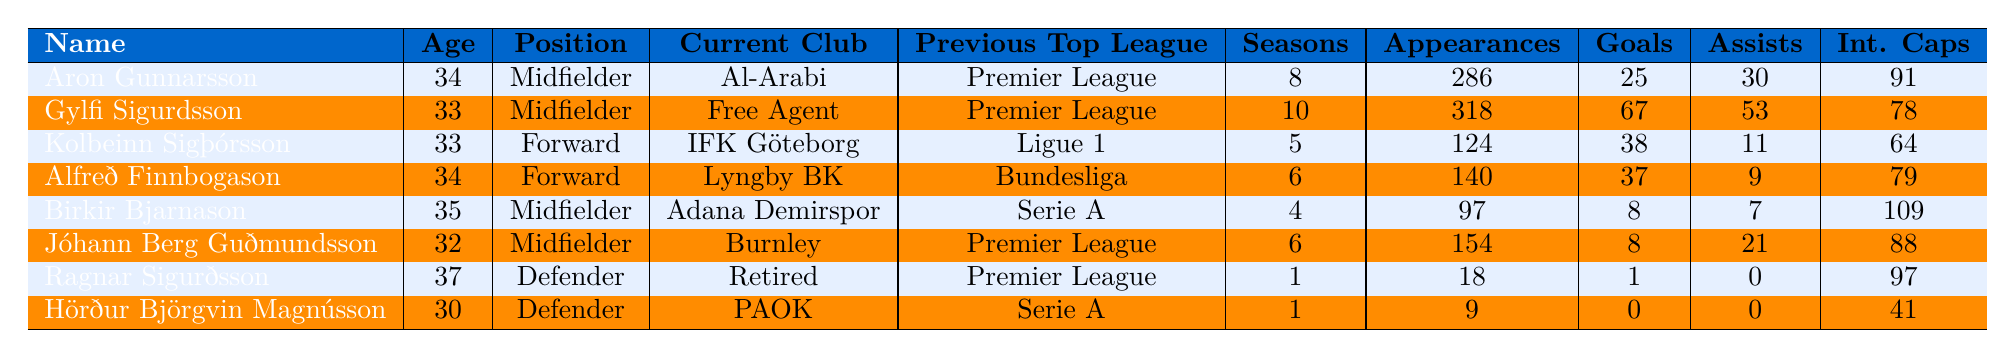What is the current club of Gylfi Sigurdsson? Gylfi Sigurdsson's current club is listed in the table under the 'Current Club' column, where it states "Free Agent."
Answer: Free Agent How many total appearances did Aron Gunnarsson have in his top league? The table shows that Aron Gunnarsson had a total of 286 appearances in the top league, as seen in the 'Total Appearances' column.
Answer: 286 Which player has the most goals scored in the top leagues? By comparing the 'Goals' column for all players, Gylfi Sigurdsson has the highest total with 67 goals scored.
Answer: Gylfi Sigurdsson What is the sum of appearances for all the players listed? To find the total appearances, sum the appearances of all players: 286 + 318 + 124 + 140 + 97 + 154 + 18 + 9 = 1,106.
Answer: 1106 Is Ragnar Sigurðsson the oldest player in the table? The ages of all the players are compared and Ragnar Sigurðsson, at 37 years old, is indeed the oldest player listed.
Answer: Yes How many assists did Birkir Bjarnason have compared to Kolbeinn Sigþórsson? Birkir Bjarnason had 7 assists and Kolbeinn Sigþórsson had 11 assists. The difference is 11 - 7 = 4.
Answer: 4 What is the average number of international caps among all players? Sum the international caps (91 + 78 + 64 + 79 + 109 + 88 + 97 + 41 = 647) and divide by the total number of players (8): 647 / 8 = 80.875.
Answer: 80.875 Which midfielder has played the most seasons in their top league? By examining the 'Seasons' column, Gylfi Sigurdsson played 10 seasons, which is the highest among midfielders.
Answer: Gylfi Sigurdsson How many players played in the Premier League? By checking the 'Previous Top League' column, four players (Aron Gunnarsson, Gylfi Sigurdsson, Jóhann Berg Guðmundsson, and Ragnar Sigurðsson) played in the Premier League.
Answer: 4 What is the total number of goals scored by all players in the table? By adding together all the goals scored: 25 + 67 + 38 + 37 + 8 + 8 + 1 + 0 = 182.
Answer: 182 